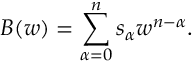Convert formula to latex. <formula><loc_0><loc_0><loc_500><loc_500>B ( w ) = \sum _ { \alpha = 0 } ^ { n } s _ { \alpha } w ^ { n - \alpha } .</formula> 